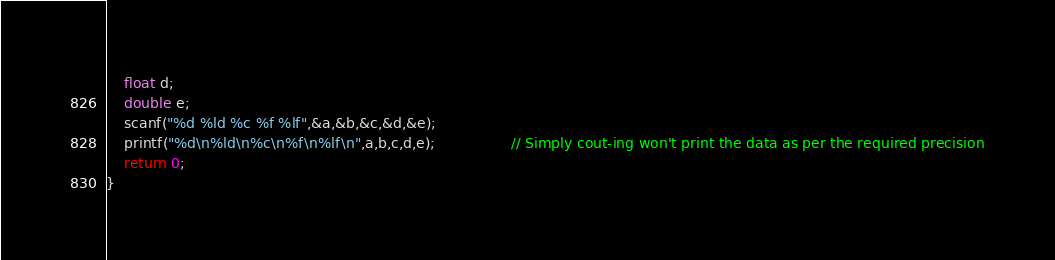<code> <loc_0><loc_0><loc_500><loc_500><_C++_>    float d;
    double e;
    scanf("%d %ld %c %f %lf",&a,&b,&c,&d,&e);
    printf("%d\n%ld\n%c\n%f\n%lf\n",a,b,c,d,e);                 // Simply cout-ing won't print the data as per the required precision
    return 0;
}
</code> 